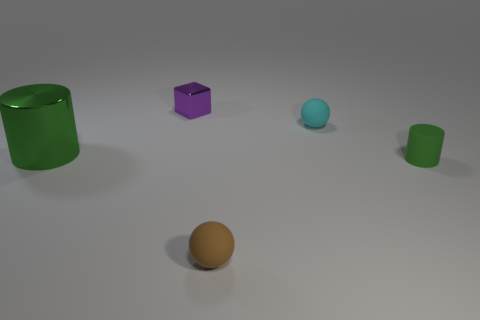Add 1 purple blocks. How many objects exist? 6 Subtract all brown spheres. How many spheres are left? 1 Subtract all cylinders. How many objects are left? 3 Subtract 1 cubes. How many cubes are left? 0 Subtract all gray blocks. Subtract all gray cylinders. How many blocks are left? 1 Subtract all matte things. Subtract all large cyan rubber blocks. How many objects are left? 2 Add 3 tiny purple metal blocks. How many tiny purple metal blocks are left? 4 Add 3 brown rubber objects. How many brown rubber objects exist? 4 Subtract 0 red spheres. How many objects are left? 5 